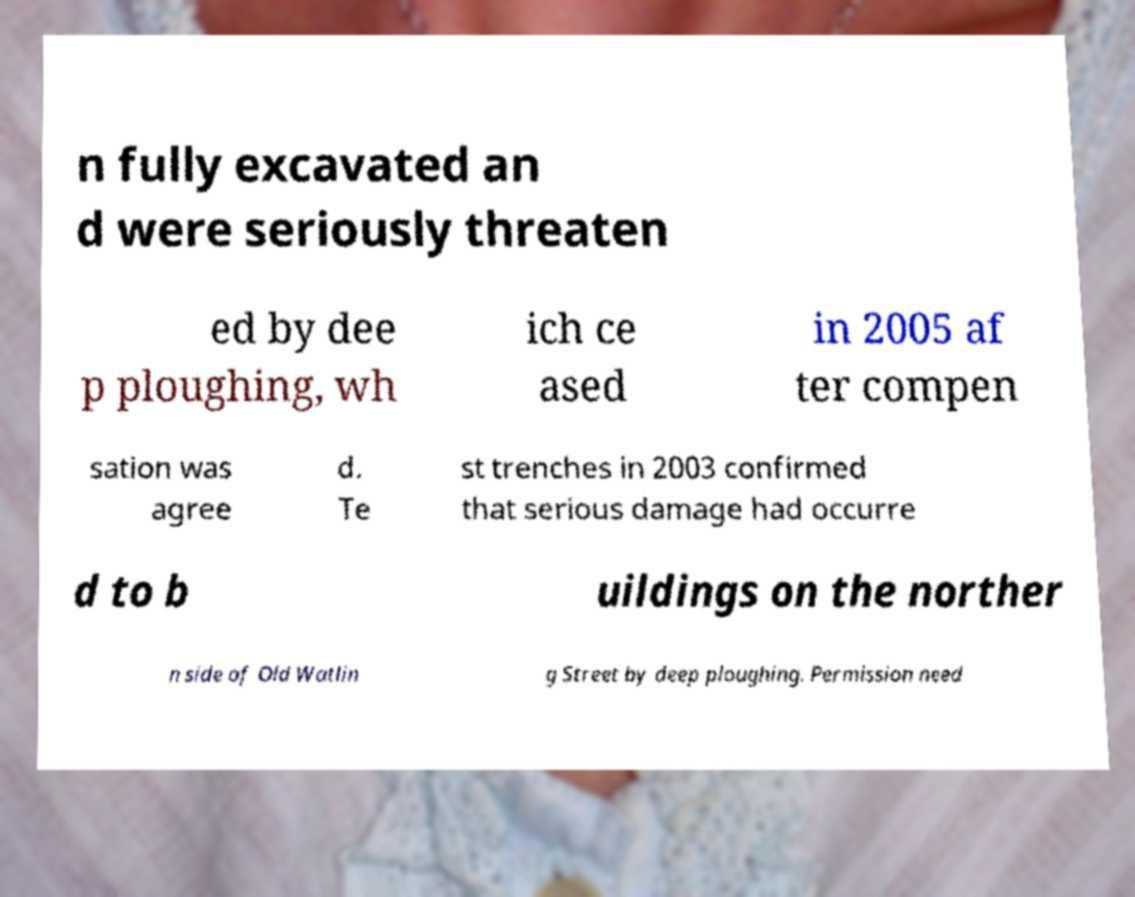Please identify and transcribe the text found in this image. n fully excavated an d were seriously threaten ed by dee p ploughing, wh ich ce ased in 2005 af ter compen sation was agree d. Te st trenches in 2003 confirmed that serious damage had occurre d to b uildings on the norther n side of Old Watlin g Street by deep ploughing. Permission need 